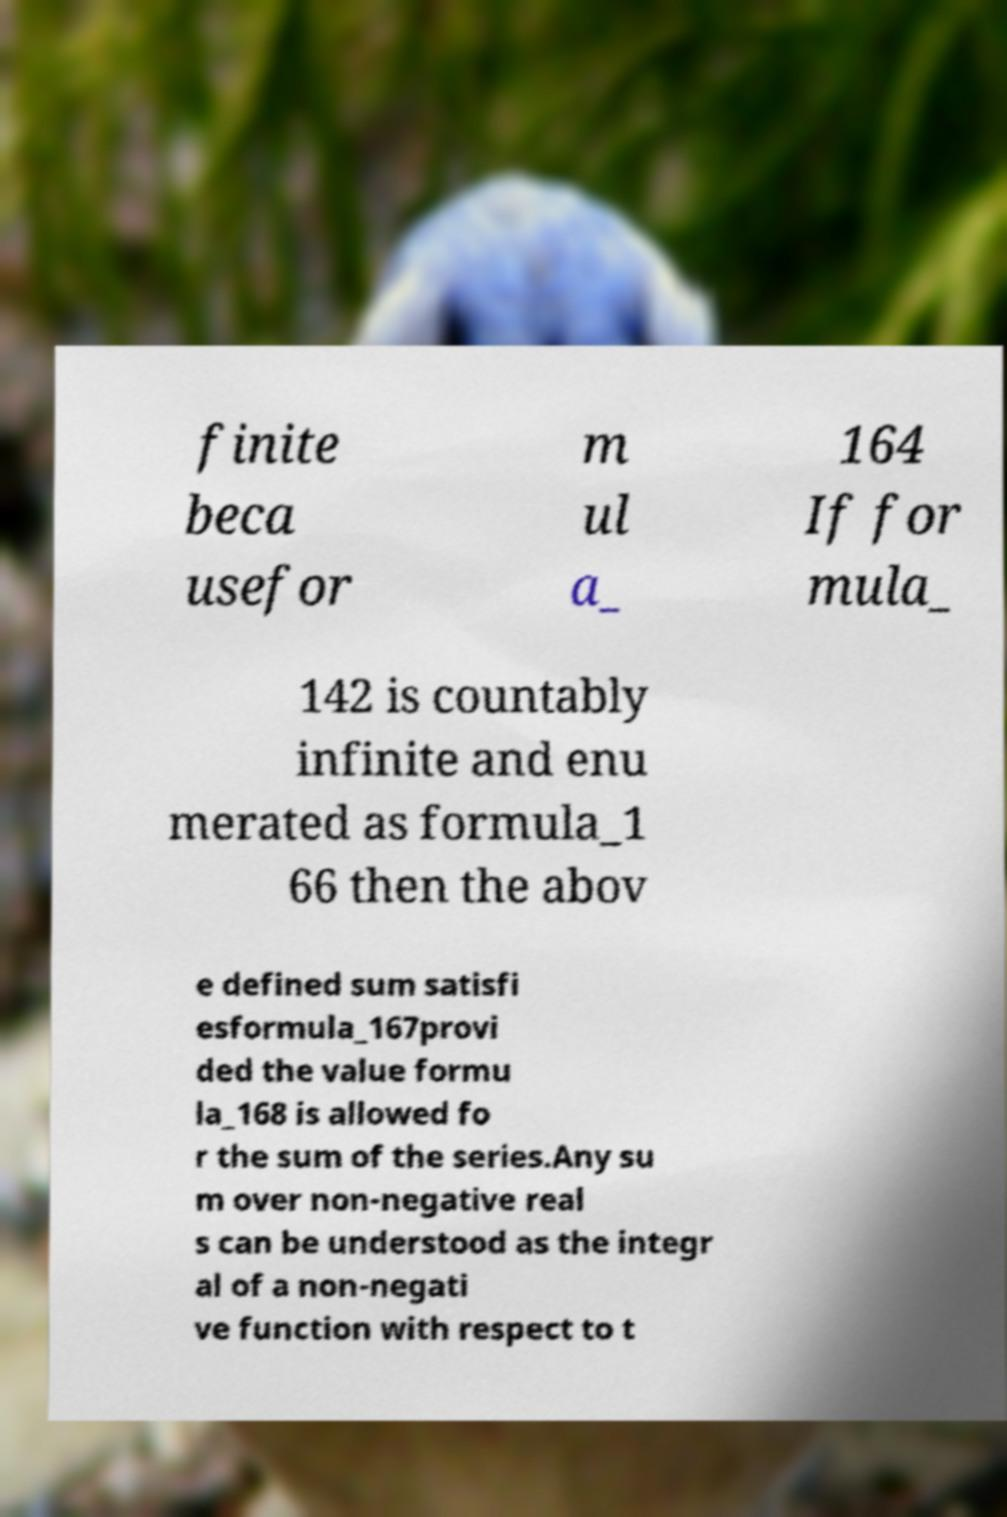What messages or text are displayed in this image? I need them in a readable, typed format. finite beca usefor m ul a_ 164 If for mula_ 142 is countably infinite and enu merated as formula_1 66 then the abov e defined sum satisfi esformula_167provi ded the value formu la_168 is allowed fo r the sum of the series.Any su m over non-negative real s can be understood as the integr al of a non-negati ve function with respect to t 